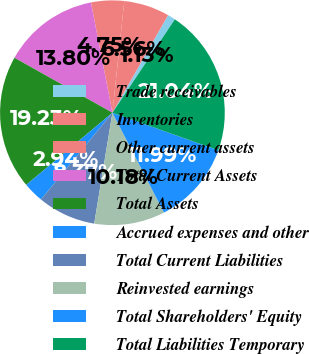Convert chart. <chart><loc_0><loc_0><loc_500><loc_500><pie_chart><fcel>Trade receivables<fcel>Inventories<fcel>Other current assets<fcel>Total Current Assets<fcel>Total Assets<fcel>Accrued expenses and other<fcel>Total Current Liabilities<fcel>Reinvested earnings<fcel>Total Shareholders' Equity<fcel>Total Liabilities Temporary<nl><fcel>1.13%<fcel>6.56%<fcel>4.75%<fcel>13.8%<fcel>19.23%<fcel>2.94%<fcel>8.37%<fcel>10.18%<fcel>11.99%<fcel>21.04%<nl></chart> 